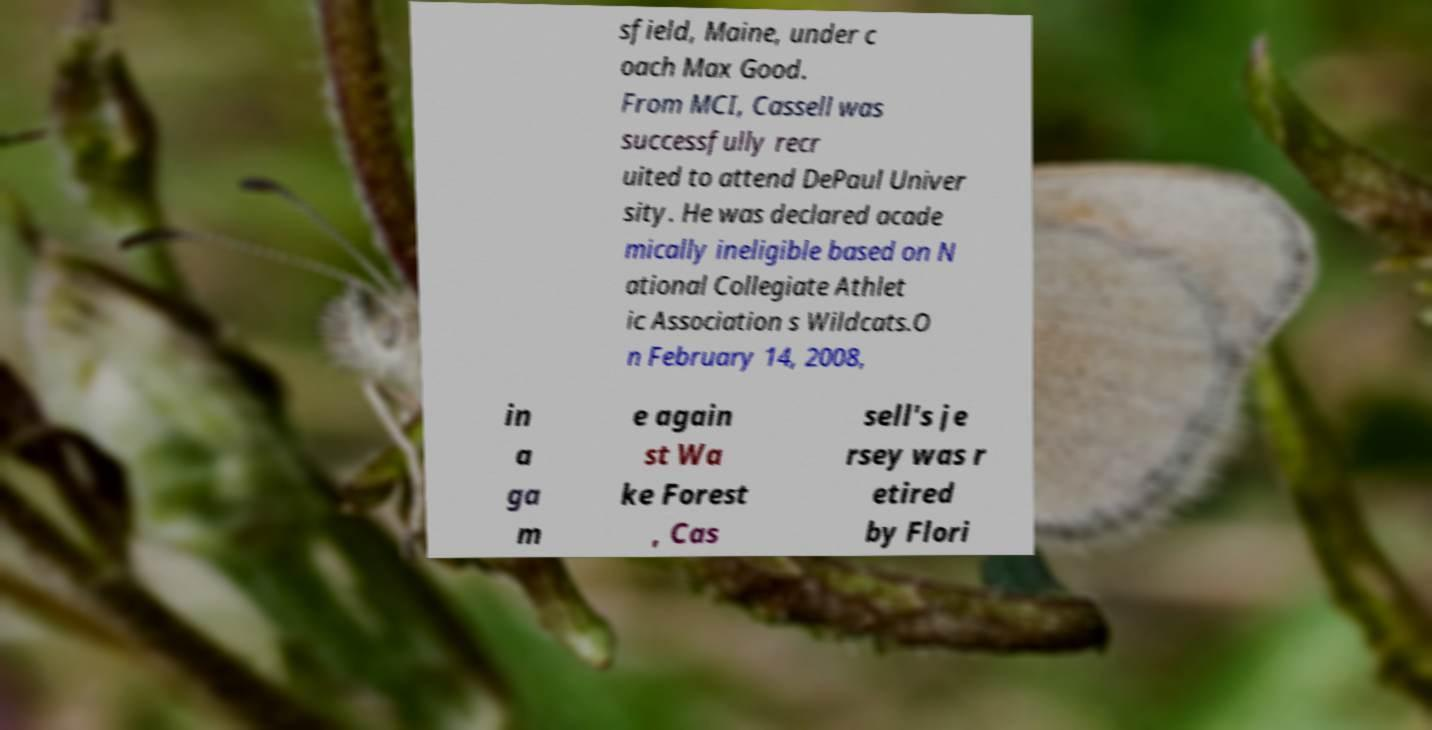There's text embedded in this image that I need extracted. Can you transcribe it verbatim? sfield, Maine, under c oach Max Good. From MCI, Cassell was successfully recr uited to attend DePaul Univer sity. He was declared acade mically ineligible based on N ational Collegiate Athlet ic Association s Wildcats.O n February 14, 2008, in a ga m e again st Wa ke Forest , Cas sell's je rsey was r etired by Flori 